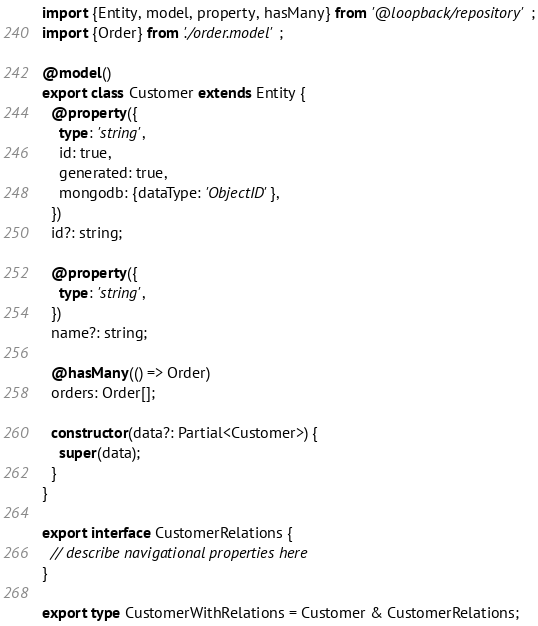Convert code to text. <code><loc_0><loc_0><loc_500><loc_500><_TypeScript_>import {Entity, model, property, hasMany} from '@loopback/repository';
import {Order} from './order.model';

@model()
export class Customer extends Entity {
  @property({
    type: 'string',
    id: true,
    generated: true,
    mongodb: {dataType: 'ObjectID'},
  })
  id?: string;

  @property({
    type: 'string',
  })
  name?: string;

  @hasMany(() => Order)
  orders: Order[];

  constructor(data?: Partial<Customer>) {
    super(data);
  }
}

export interface CustomerRelations {
  // describe navigational properties here
}

export type CustomerWithRelations = Customer & CustomerRelations;
</code> 